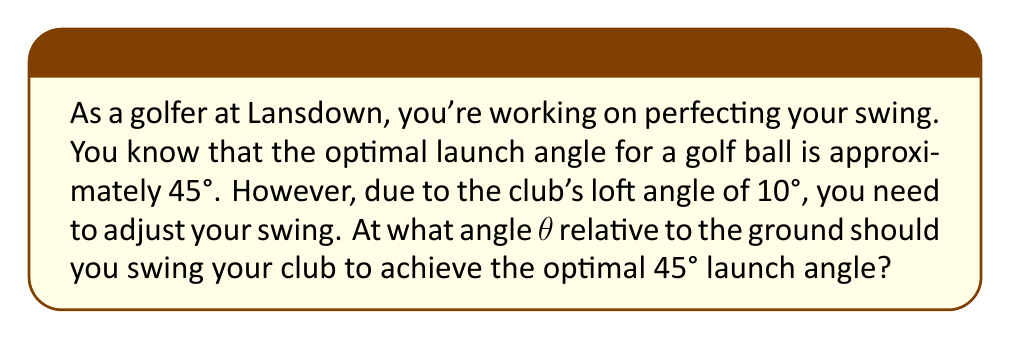Help me with this question. Let's approach this step-by-step using trigonometry:

1) We know that the optimal launch angle is 45°, and the club's loft angle is 10°.

2) The launch angle is the sum of the swing angle (θ) and the loft angle:

   $$ 45° = θ + 10° $$

3) To solve for θ, we simply subtract 10° from both sides:

   $$ θ = 45° - 10° $$

4) Simplifying:

   $$ θ = 35° $$

5) To verify, we can add the swing angle and the loft angle:

   $$ 35° + 10° = 45° $$

   This confirms that a 35° swing angle combined with the 10° loft angle will result in the optimal 45° launch angle.

[asy]
import geometry;

size(200);
draw((0,0)--(100,0), arrow=Arrow(TeXHead));
draw((0,0)--(100,70), arrow=Arrow(TeXHead));
draw((0,0)--(100,100), arrow=Arrow(TeXHead));

label("Ground", (50,-5));
label("Club path", (80,30));
label("Ball trajectory", (80,80));

draw(arc((0,0),20,0,35), arrow=Arrow(TeXHead));
label("35°", (15,10));

draw(arc((0,0),30,35,45), arrow=Arrow(TeXHead));
label("10°", (25,30));

draw(arc((0,0),40,0,45), arrow=Arrow(TeXHead));
label("45°", (35,25));
[/asy]
Answer: 35° 